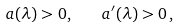<formula> <loc_0><loc_0><loc_500><loc_500>a ( \lambda ) > 0 , \quad a ^ { \prime } ( \lambda ) > 0 \, ,</formula> 